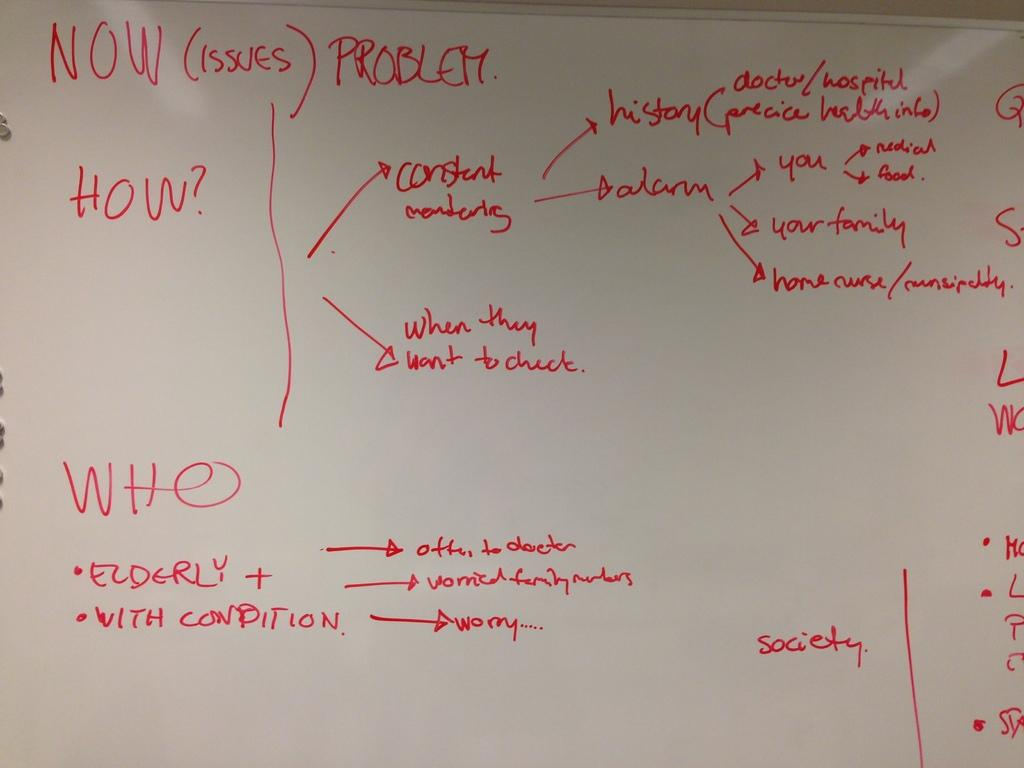<image>
Create a compact narrative representing the image presented. A white board with Now How and Who is written in red 